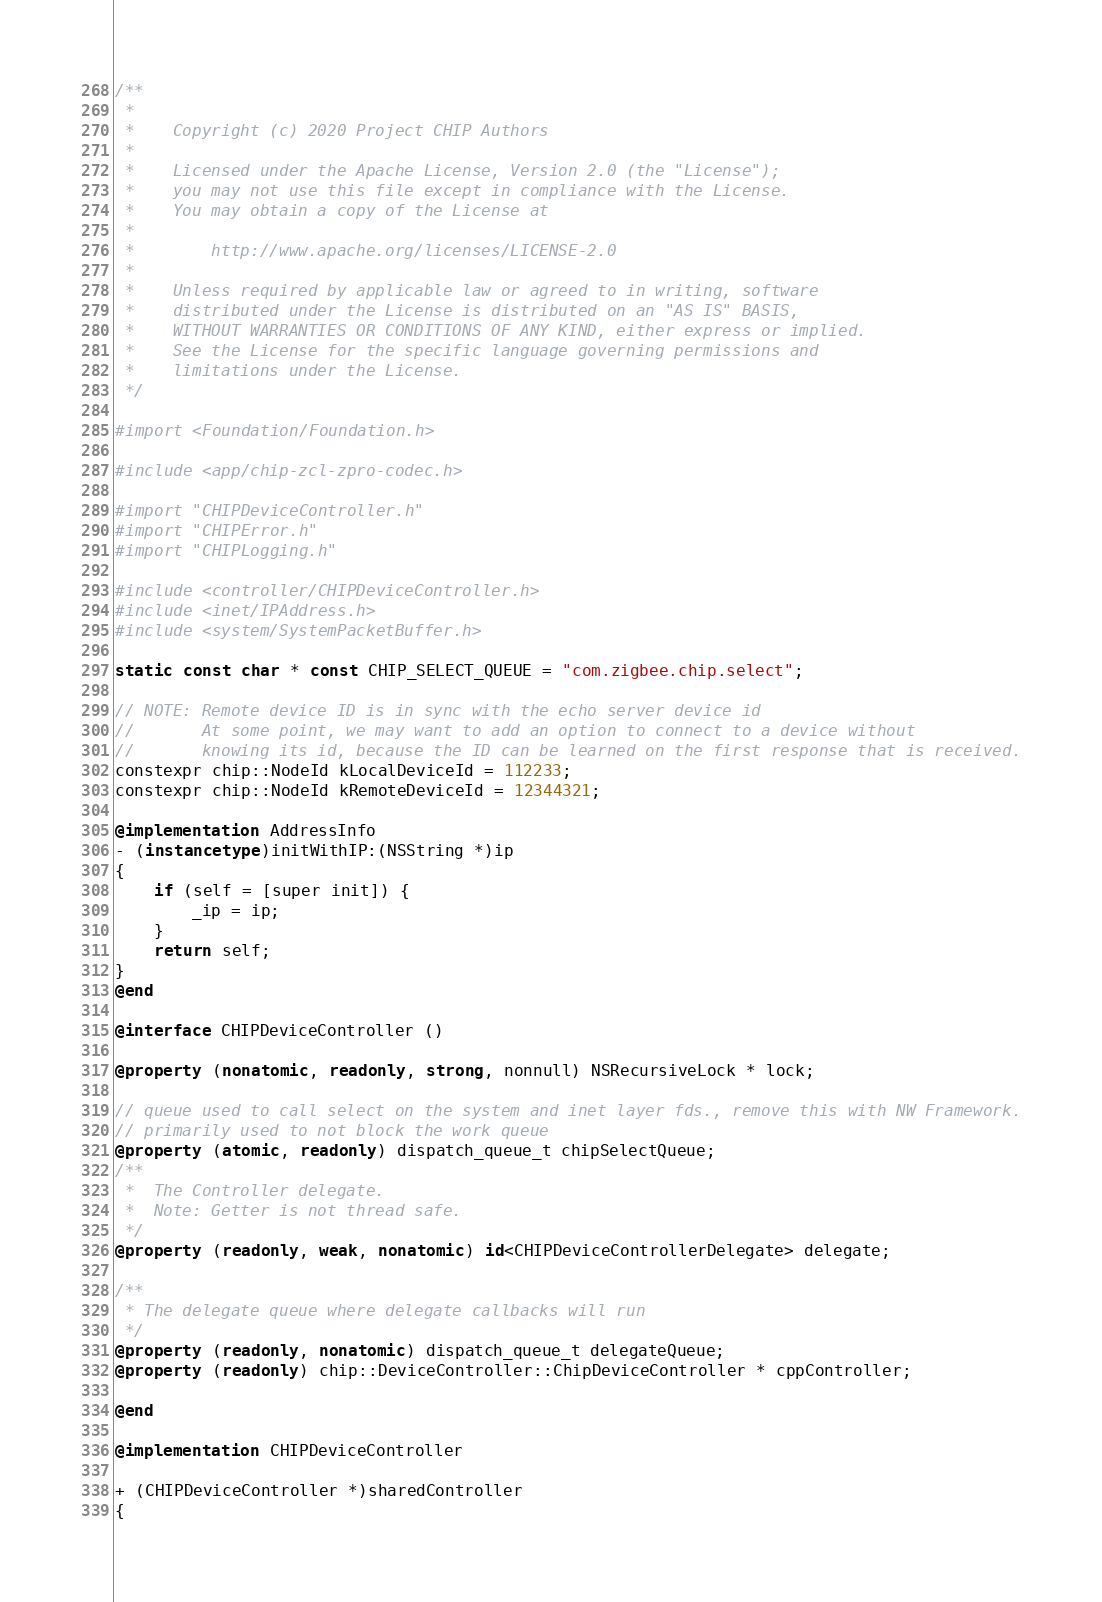Convert code to text. <code><loc_0><loc_0><loc_500><loc_500><_ObjectiveC_>/**
 *
 *    Copyright (c) 2020 Project CHIP Authors
 *
 *    Licensed under the Apache License, Version 2.0 (the "License");
 *    you may not use this file except in compliance with the License.
 *    You may obtain a copy of the License at
 *
 *        http://www.apache.org/licenses/LICENSE-2.0
 *
 *    Unless required by applicable law or agreed to in writing, software
 *    distributed under the License is distributed on an "AS IS" BASIS,
 *    WITHOUT WARRANTIES OR CONDITIONS OF ANY KIND, either express or implied.
 *    See the License for the specific language governing permissions and
 *    limitations under the License.
 */

#import <Foundation/Foundation.h>

#include <app/chip-zcl-zpro-codec.h>

#import "CHIPDeviceController.h"
#import "CHIPError.h"
#import "CHIPLogging.h"

#include <controller/CHIPDeviceController.h>
#include <inet/IPAddress.h>
#include <system/SystemPacketBuffer.h>

static const char * const CHIP_SELECT_QUEUE = "com.zigbee.chip.select";

// NOTE: Remote device ID is in sync with the echo server device id
//       At some point, we may want to add an option to connect to a device without
//       knowing its id, because the ID can be learned on the first response that is received.
constexpr chip::NodeId kLocalDeviceId = 112233;
constexpr chip::NodeId kRemoteDeviceId = 12344321;

@implementation AddressInfo
- (instancetype)initWithIP:(NSString *)ip
{
    if (self = [super init]) {
        _ip = ip;
    }
    return self;
}
@end

@interface CHIPDeviceController ()

@property (nonatomic, readonly, strong, nonnull) NSRecursiveLock * lock;

// queue used to call select on the system and inet layer fds., remove this with NW Framework.
// primarily used to not block the work queue
@property (atomic, readonly) dispatch_queue_t chipSelectQueue;
/**
 *  The Controller delegate.
 *  Note: Getter is not thread safe.
 */
@property (readonly, weak, nonatomic) id<CHIPDeviceControllerDelegate> delegate;

/**
 * The delegate queue where delegate callbacks will run
 */
@property (readonly, nonatomic) dispatch_queue_t delegateQueue;
@property (readonly) chip::DeviceController::ChipDeviceController * cppController;

@end

@implementation CHIPDeviceController

+ (CHIPDeviceController *)sharedController
{</code> 